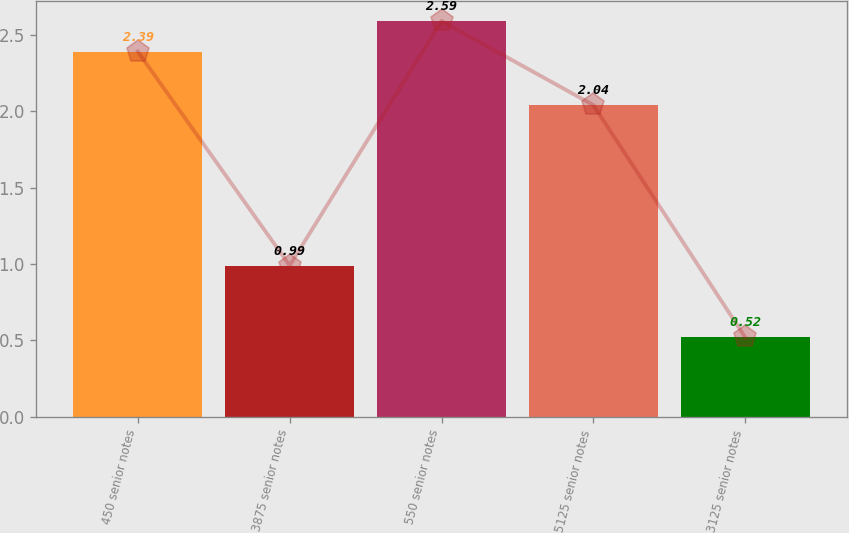Convert chart to OTSL. <chart><loc_0><loc_0><loc_500><loc_500><bar_chart><fcel>450 senior notes<fcel>3875 senior notes<fcel>550 senior notes<fcel>5125 senior notes<fcel>3125 senior notes<nl><fcel>2.39<fcel>0.99<fcel>2.59<fcel>2.04<fcel>0.52<nl></chart> 